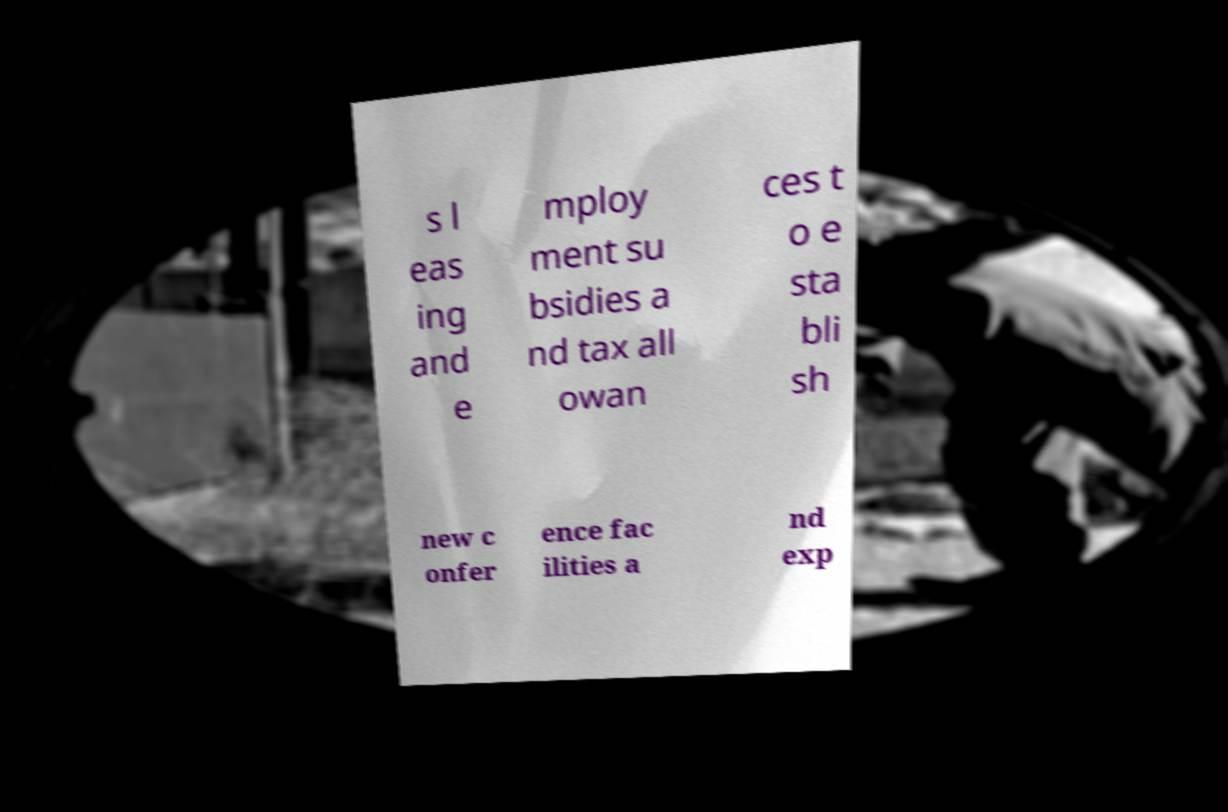Can you accurately transcribe the text from the provided image for me? s l eas ing and e mploy ment su bsidies a nd tax all owan ces t o e sta bli sh new c onfer ence fac ilities a nd exp 